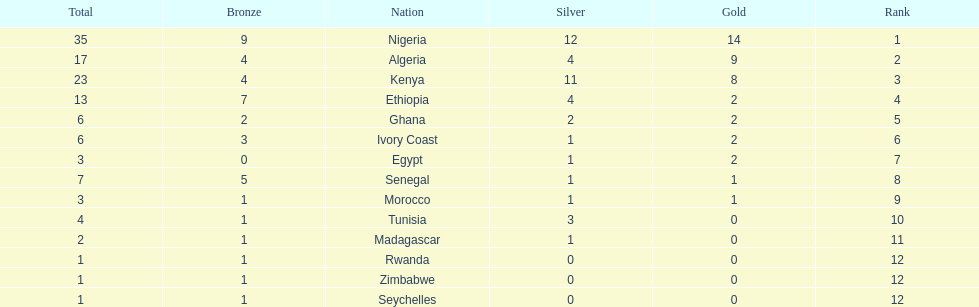The country that won the most medals was? Nigeria. 